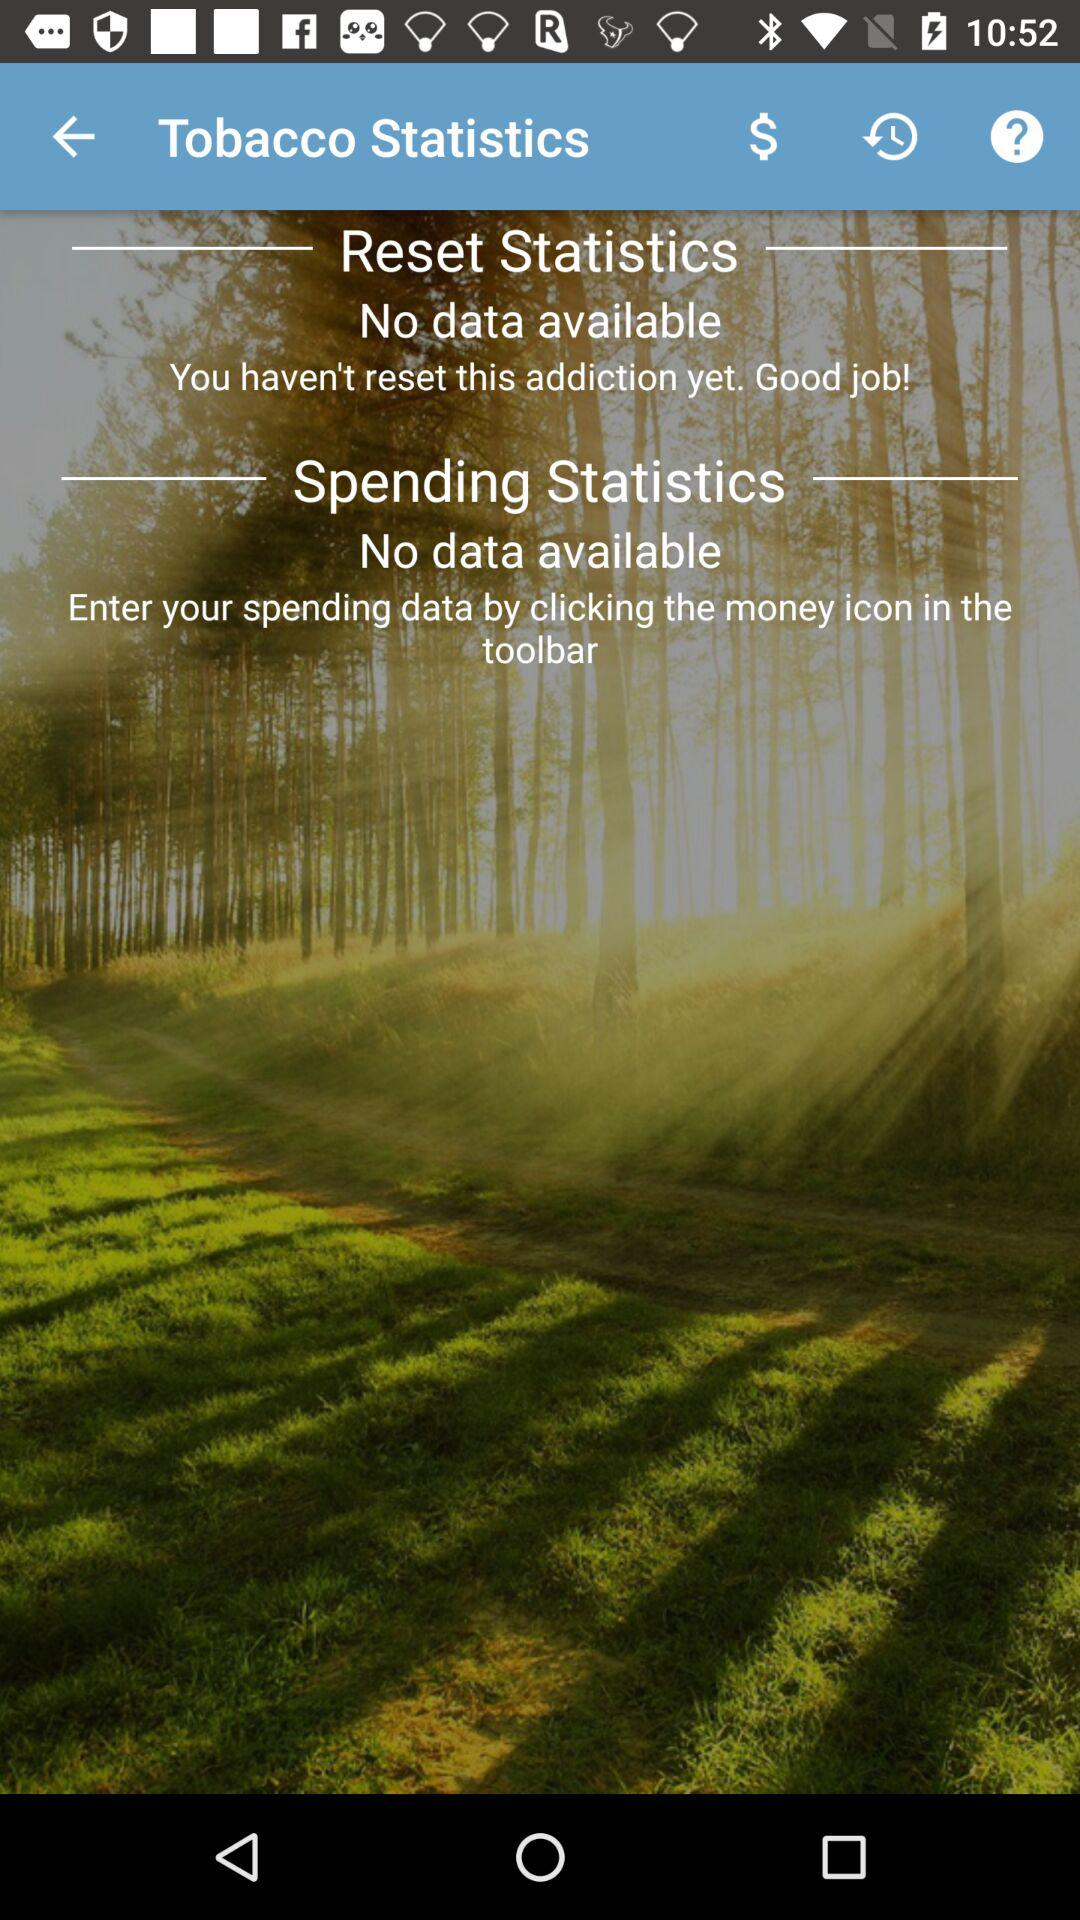How many statistics are shown for tobacco? 2 